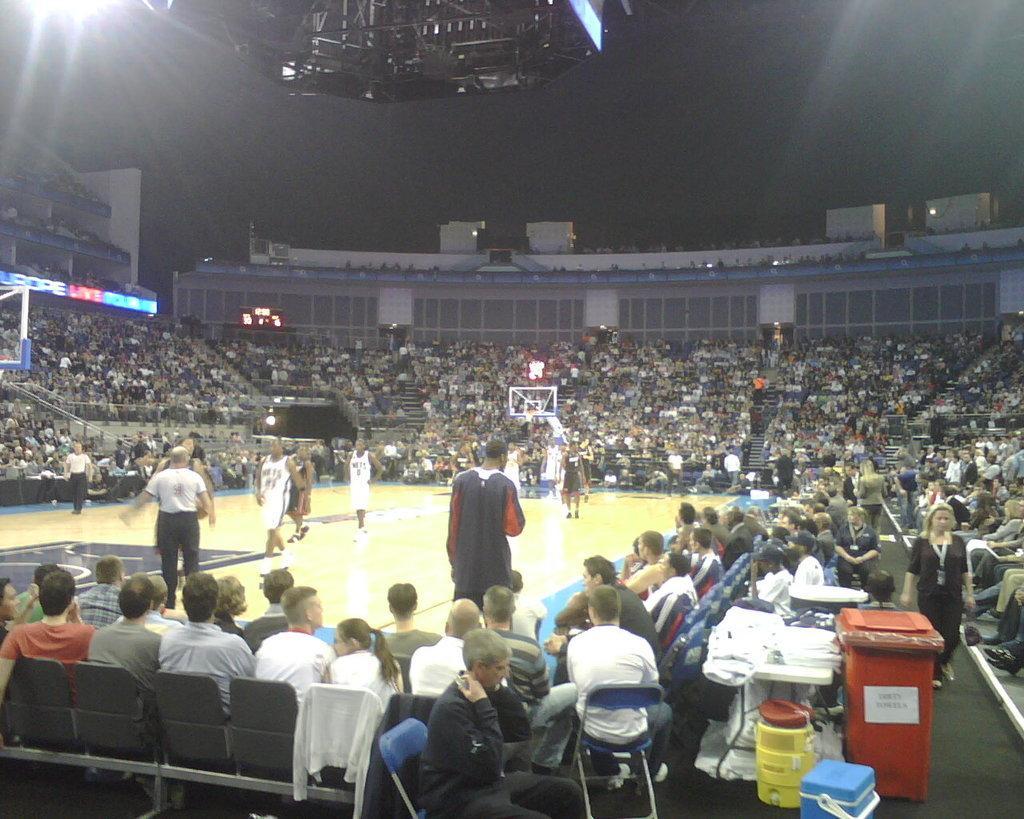Could you give a brief overview of what you see in this image? In this image there are players playing basket ball, around them there are people sitting on chairs and there is a dustbin and a table, on that table there are few items. 